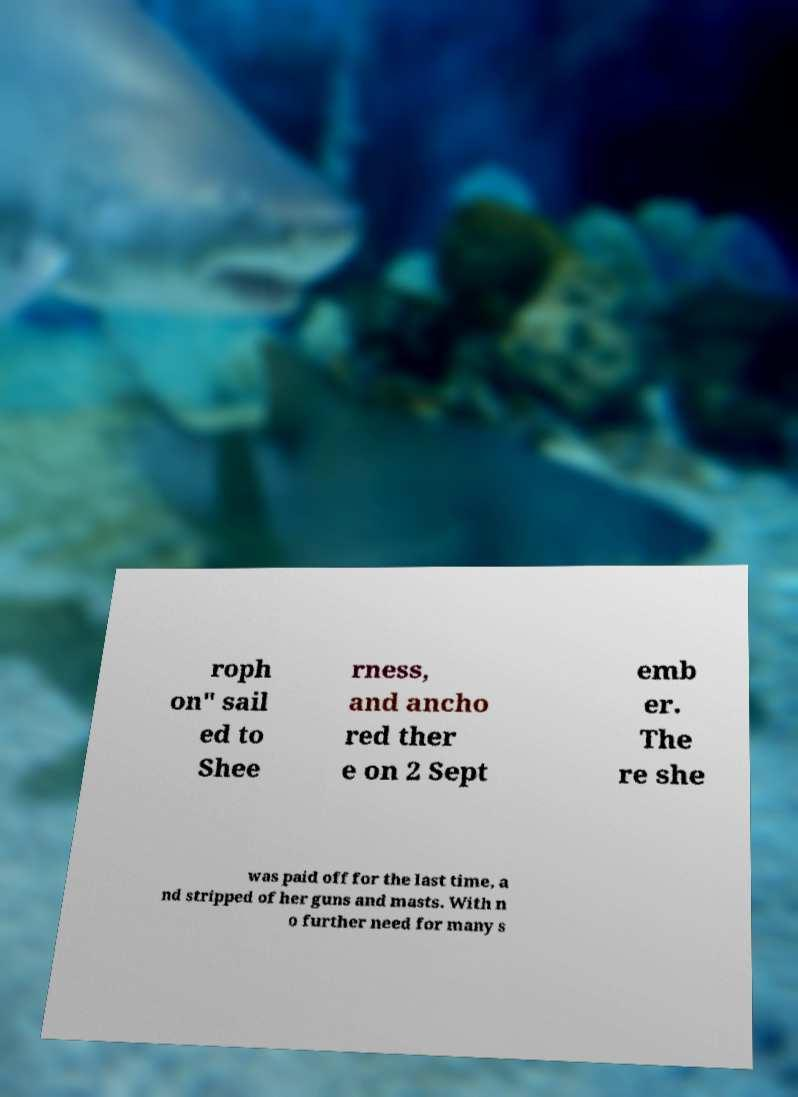For documentation purposes, I need the text within this image transcribed. Could you provide that? roph on" sail ed to Shee rness, and ancho red ther e on 2 Sept emb er. The re she was paid off for the last time, a nd stripped of her guns and masts. With n o further need for many s 